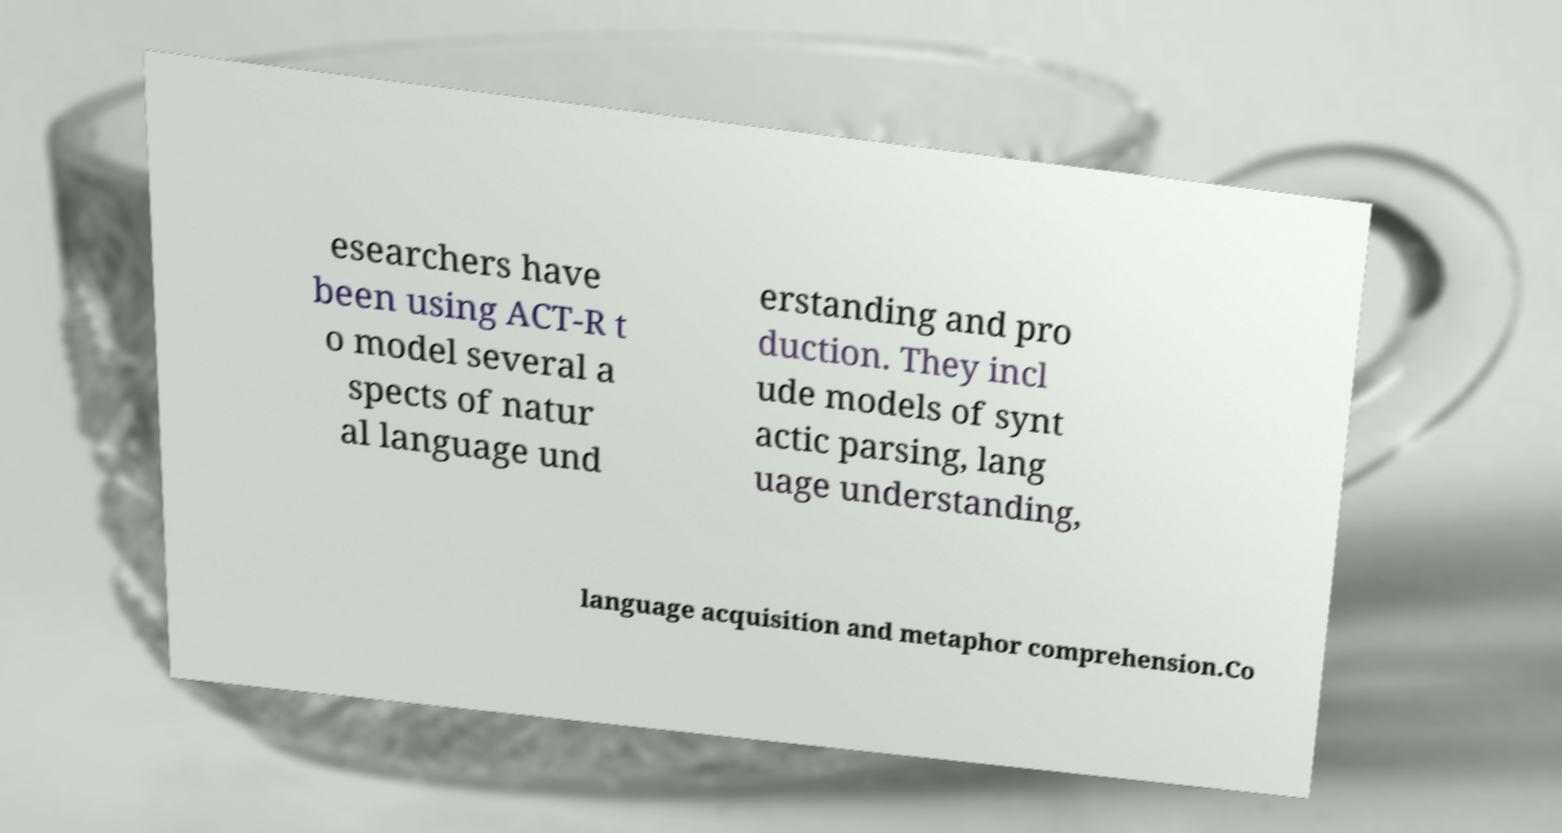Could you assist in decoding the text presented in this image and type it out clearly? esearchers have been using ACT-R t o model several a spects of natur al language und erstanding and pro duction. They incl ude models of synt actic parsing, lang uage understanding, language acquisition and metaphor comprehension.Co 